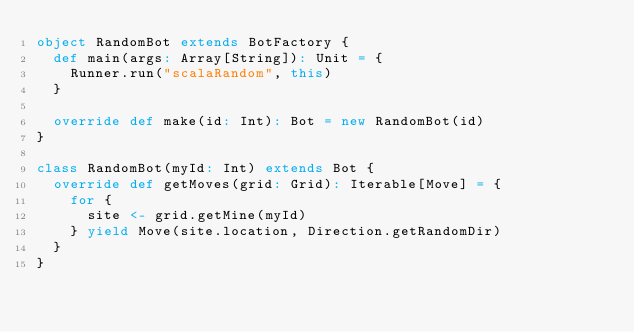Convert code to text. <code><loc_0><loc_0><loc_500><loc_500><_Scala_>object RandomBot extends BotFactory {
  def main(args: Array[String]): Unit = {
    Runner.run("scalaRandom", this)
  }

  override def make(id: Int): Bot = new RandomBot(id)
}

class RandomBot(myId: Int) extends Bot {
  override def getMoves(grid: Grid): Iterable[Move] = {
    for {
      site <- grid.getMine(myId)
    } yield Move(site.location, Direction.getRandomDir)
  }
}</code> 